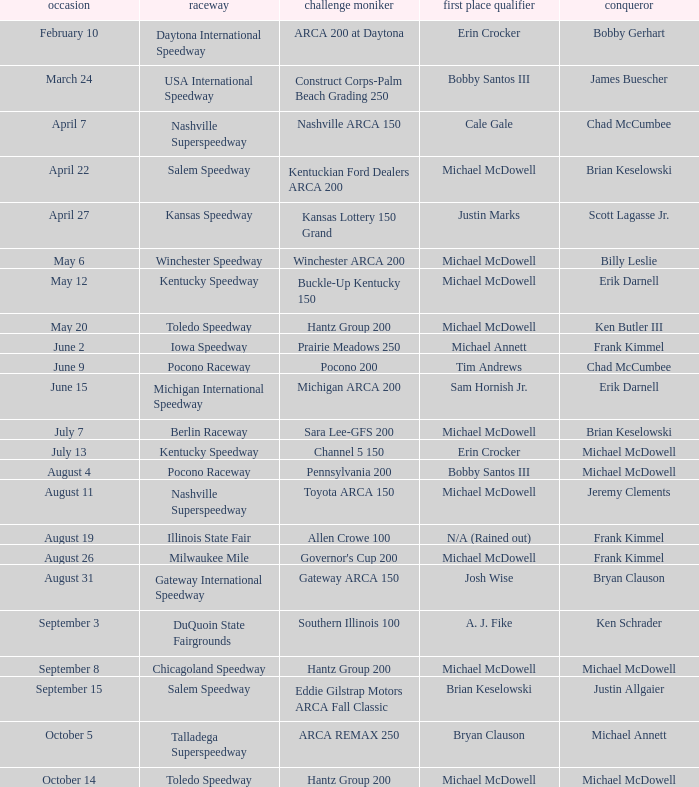Tell me the event name for michael mcdowell and billy leslie Winchester ARCA 200. 